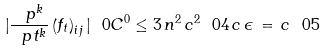Convert formula to latex. <formula><loc_0><loc_0><loc_500><loc_500>| \frac { \ p ^ { k } } { \ p t ^ { k } } \left ( f _ { t } \right ) _ { i j } | \ 0 { C ^ { 0 } } \leq 3 \, n ^ { 2 } \, c ^ { 2 } \ 0 { 4 } \, c \, \epsilon \, = \, c \ 0 { 5 }</formula> 